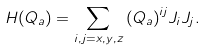<formula> <loc_0><loc_0><loc_500><loc_500>H ( Q _ { a } ) = \sum _ { i , j = x , y , z } { ( Q _ { a } ) } ^ { i j } J _ { i } J _ { j } .</formula> 